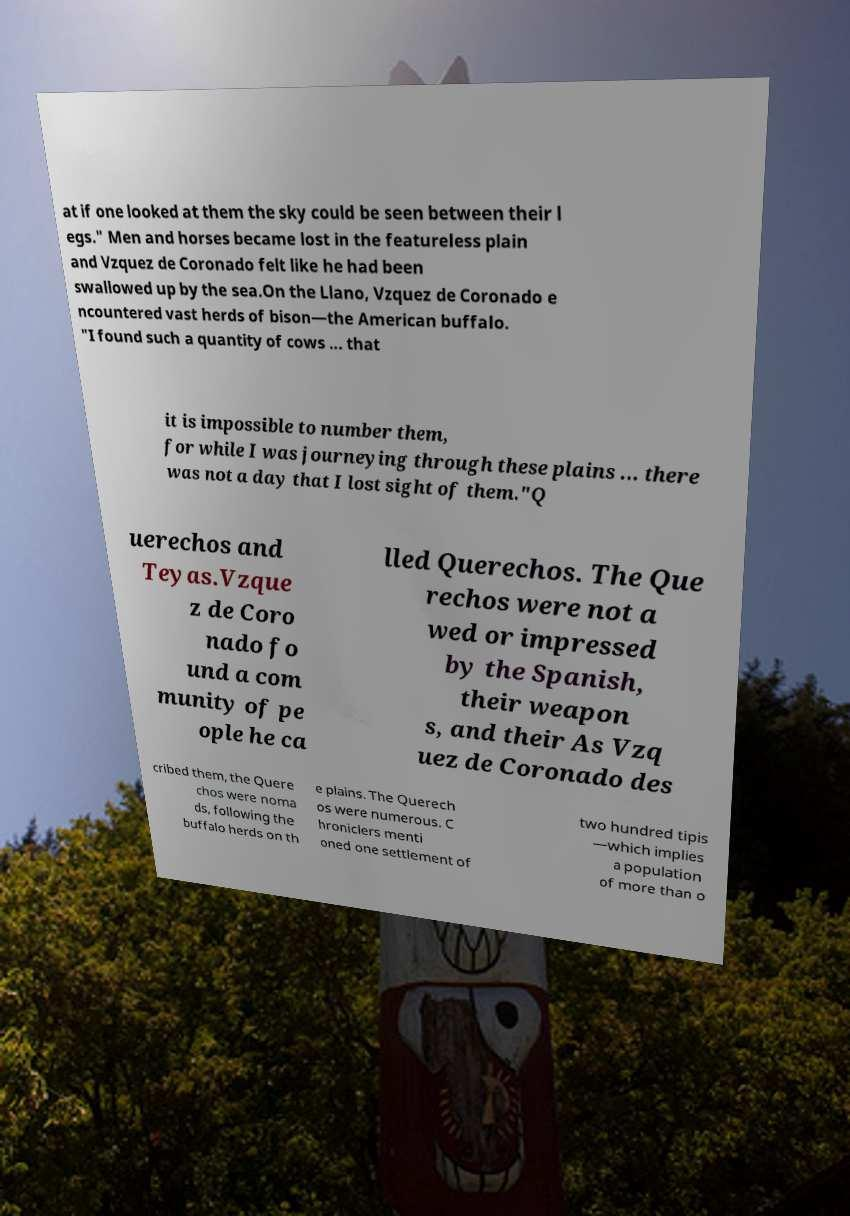Could you assist in decoding the text presented in this image and type it out clearly? at if one looked at them the sky could be seen between their l egs." Men and horses became lost in the featureless plain and Vzquez de Coronado felt like he had been swallowed up by the sea.On the Llano, Vzquez de Coronado e ncountered vast herds of bison—the American buffalo. "I found such a quantity of cows ... that it is impossible to number them, for while I was journeying through these plains ... there was not a day that I lost sight of them."Q uerechos and Teyas.Vzque z de Coro nado fo und a com munity of pe ople he ca lled Querechos. The Que rechos were not a wed or impressed by the Spanish, their weapon s, and their As Vzq uez de Coronado des cribed them, the Quere chos were noma ds, following the buffalo herds on th e plains. The Querech os were numerous. C hroniclers menti oned one settlement of two hundred tipis —which implies a population of more than o 